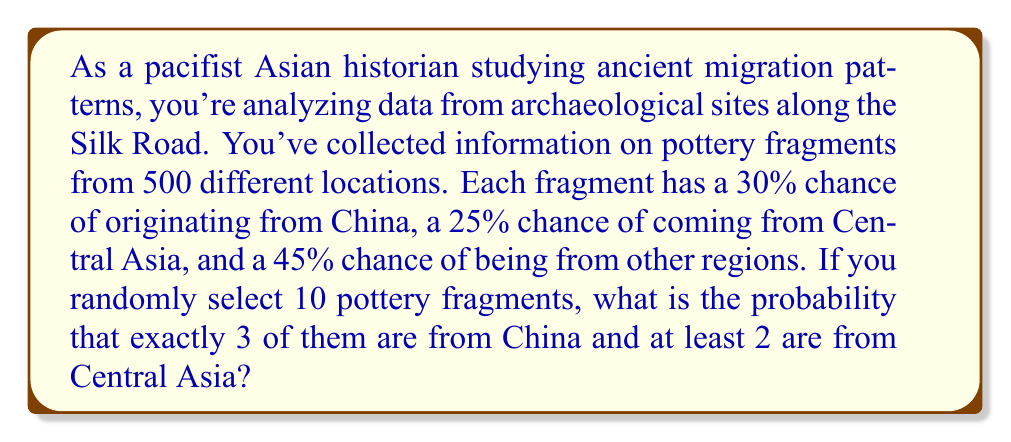Teach me how to tackle this problem. To solve this problem, we'll use the binomial probability distribution and the concept of complementary events. Let's break it down step-by-step:

1. First, we need to calculate the probability of exactly 3 fragments being from China:
   $$P(\text{3 from China}) = \binom{10}{3} \cdot 0.3^3 \cdot 0.7^7$$
   
   $$= 120 \cdot 0.027 \cdot 0.0824 = 0.2668$$

2. Now, we need to calculate the probability of at least 2 fragments being from Central Asia out of the remaining 7 fragments:
   $$P(\text{at least 2 from Central Asia}) = 1 - P(\text{0 or 1 from Central Asia})$$
   
   $$= 1 - [\binom{7}{0} \cdot 0.25^0 \cdot 0.75^7 + \binom{7}{1} \cdot 0.25^1 \cdot 0.75^6]$$
   
   $$= 1 - [0.1335 + 0.3115] = 0.5550$$

3. The probability of both events occurring together is the product of their individual probabilities:
   $$P(\text{3 from China AND at least 2 from Central Asia}) = 0.2668 \cdot 0.5550 = 0.1481$$

This calculation assumes independence between the events, which is reasonable given the random selection of fragments.
Answer: The probability that exactly 3 out of 10 randomly selected pottery fragments are from China and at least 2 are from Central Asia is approximately 0.1481 or 14.81%. 